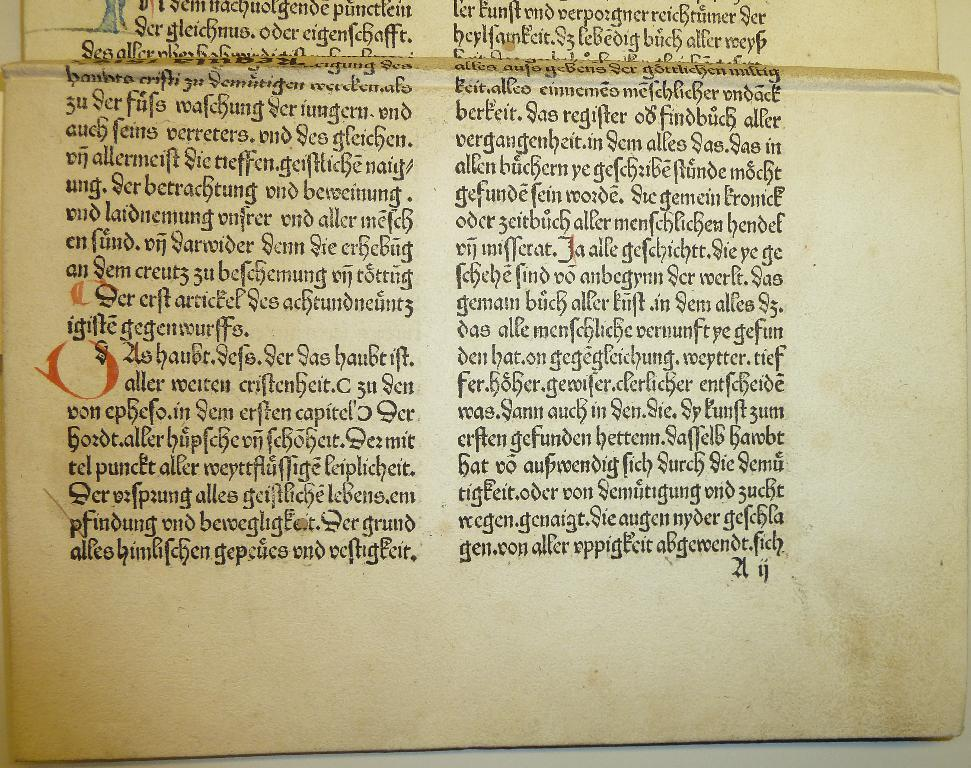<image>
Write a terse but informative summary of the picture. the word alles is on the page with a lot of writing on it 